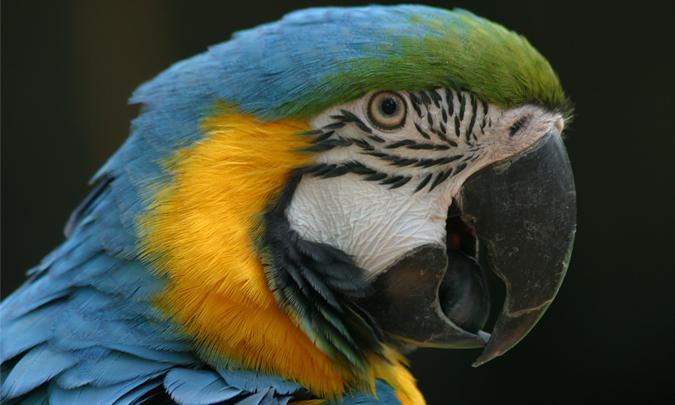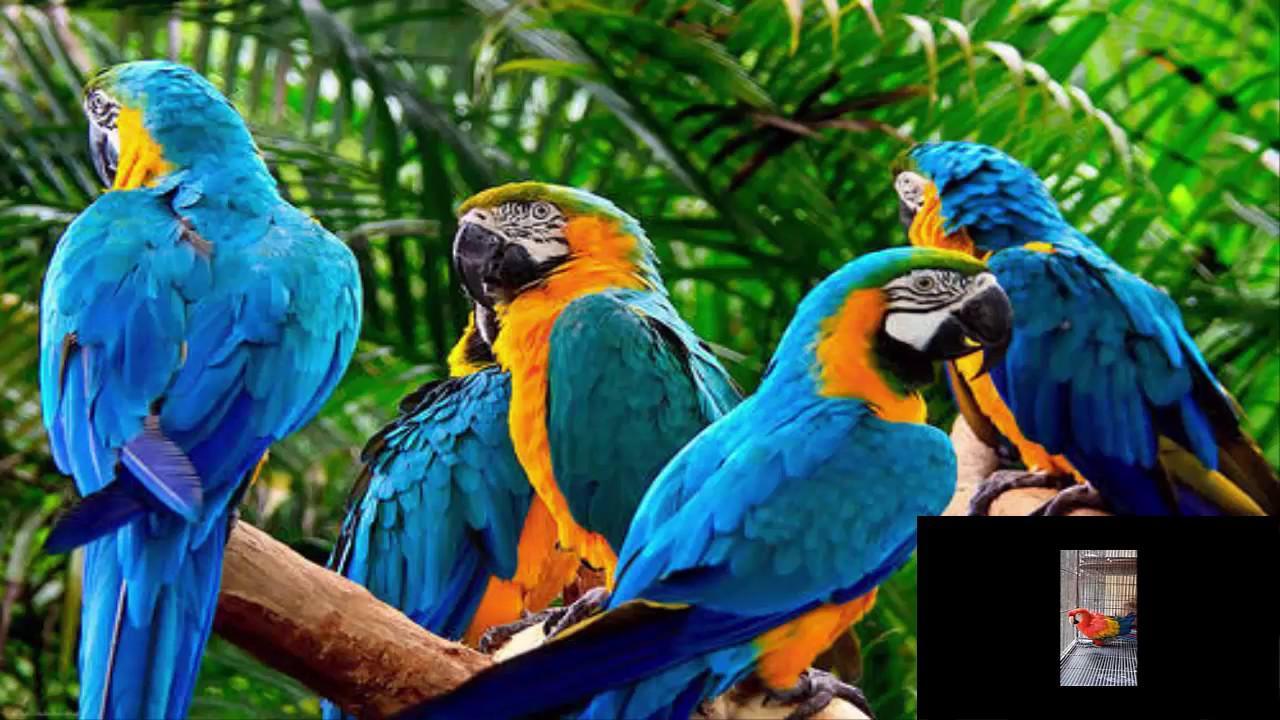The first image is the image on the left, the second image is the image on the right. Analyze the images presented: Is the assertion "There are at least two parrots in the right image." valid? Answer yes or no. Yes. The first image is the image on the left, the second image is the image on the right. Analyze the images presented: Is the assertion "All birds shown have blue and yellow coloring, and at least one image has green fanning fronds in the background." valid? Answer yes or no. Yes. 